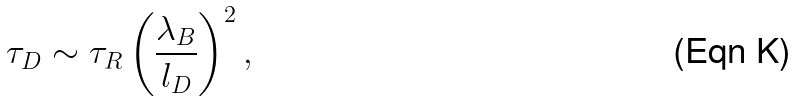<formula> <loc_0><loc_0><loc_500><loc_500>\tau _ { D } \sim \tau _ { R } \left ( \frac { \lambda _ { B } } { l _ { D } } \right ) ^ { 2 } ,</formula> 